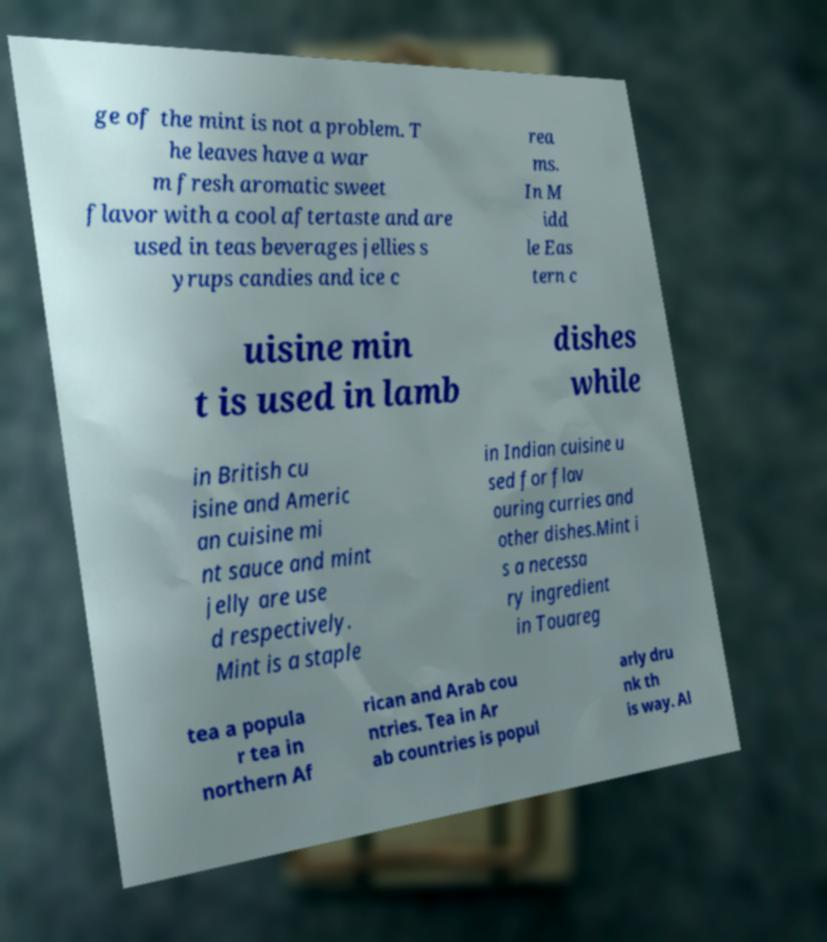Please read and relay the text visible in this image. What does it say? ge of the mint is not a problem. T he leaves have a war m fresh aromatic sweet flavor with a cool aftertaste and are used in teas beverages jellies s yrups candies and ice c rea ms. In M idd le Eas tern c uisine min t is used in lamb dishes while in British cu isine and Americ an cuisine mi nt sauce and mint jelly are use d respectively. Mint is a staple in Indian cuisine u sed for flav ouring curries and other dishes.Mint i s a necessa ry ingredient in Touareg tea a popula r tea in northern Af rican and Arab cou ntries. Tea in Ar ab countries is popul arly dru nk th is way. Al 